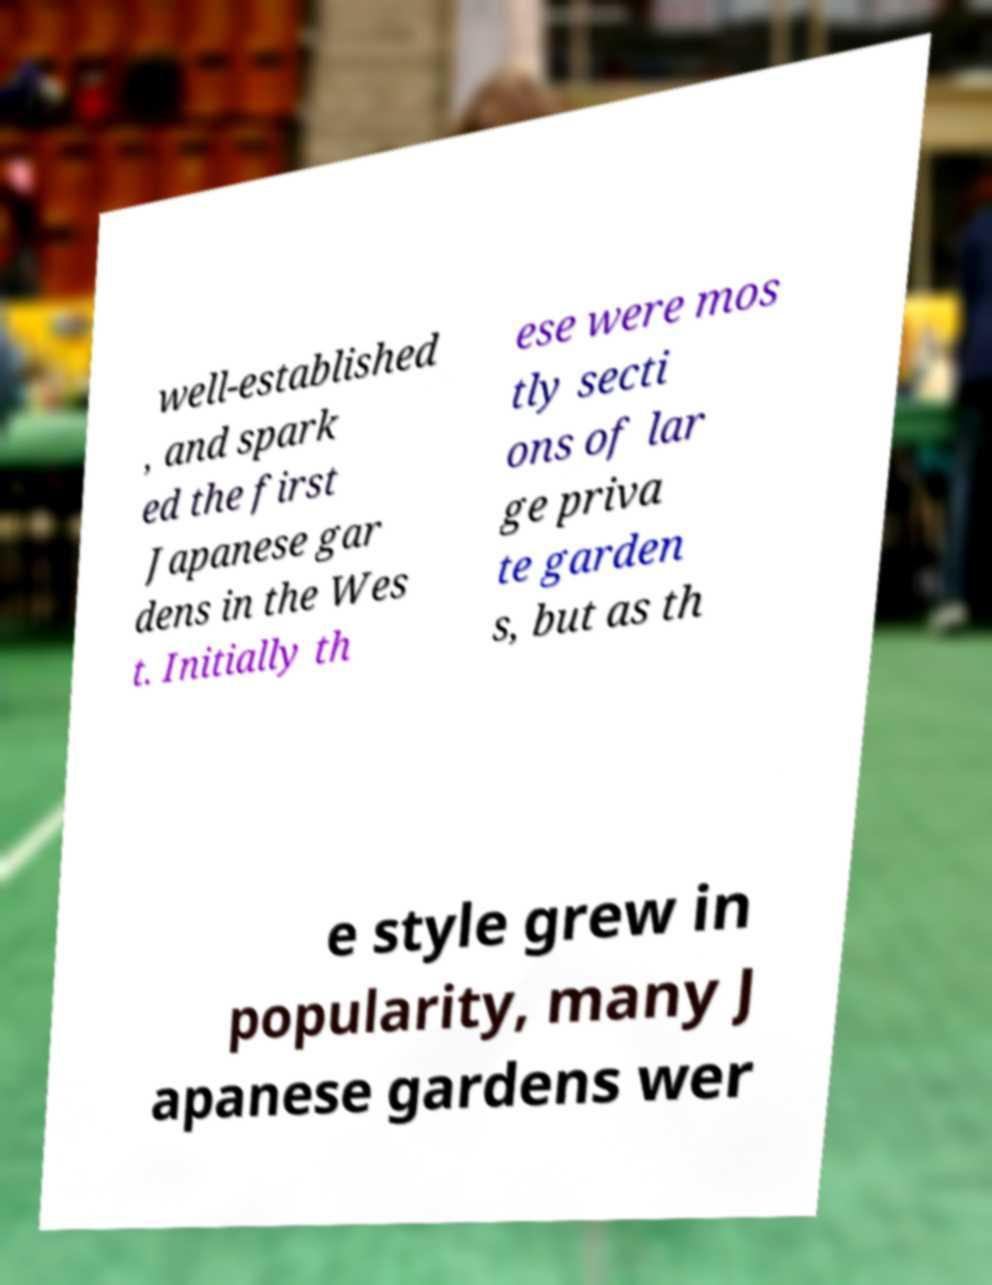For documentation purposes, I need the text within this image transcribed. Could you provide that? well-established , and spark ed the first Japanese gar dens in the Wes t. Initially th ese were mos tly secti ons of lar ge priva te garden s, but as th e style grew in popularity, many J apanese gardens wer 